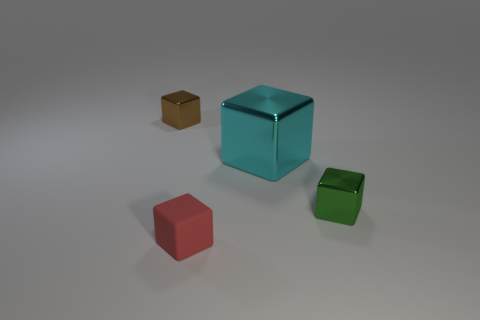What number of small blocks are both behind the small green object and in front of the small green cube?
Offer a very short reply. 0. What is the shape of the brown metallic object that is the same size as the red thing?
Give a very brief answer. Cube. The green metallic cube is what size?
Offer a terse response. Small. What material is the small block that is behind the small metallic cube on the right side of the small cube that is on the left side of the red thing made of?
Give a very brief answer. Metal. There is a big block that is made of the same material as the tiny green thing; what color is it?
Offer a very short reply. Cyan. How many small green shiny objects are behind the thing that is in front of the small metallic block on the right side of the red block?
Your answer should be compact. 1. How many objects are either small metal blocks that are on the right side of the brown thing or small brown rubber cubes?
Keep it short and to the point. 1. There is a thing in front of the shiny cube that is on the right side of the cyan thing; what is its shape?
Keep it short and to the point. Cube. Are there fewer red blocks that are in front of the small brown block than objects that are on the left side of the big cube?
Keep it short and to the point. Yes. There is a cyan metallic thing that is the same shape as the rubber thing; what is its size?
Make the answer very short. Large. 